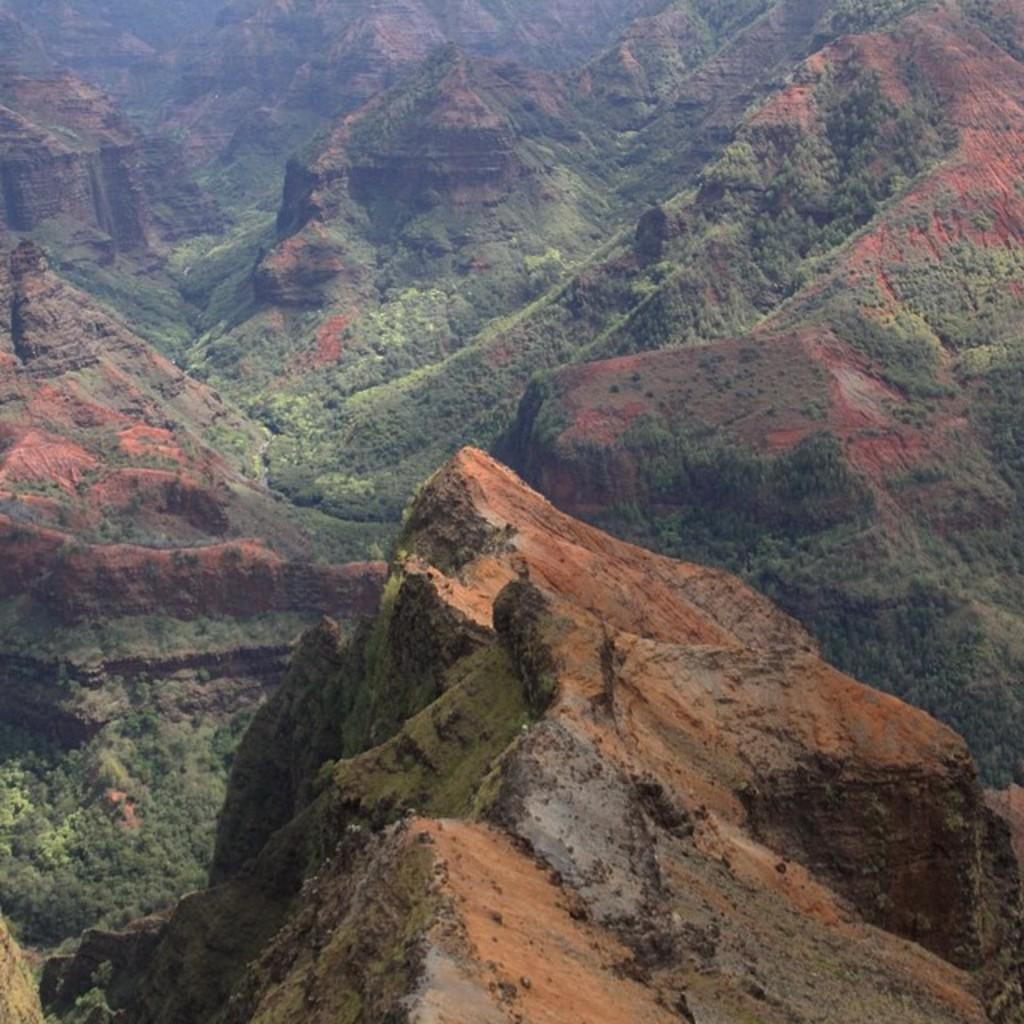What type of natural formation can be seen in the image? There are mountains in the image. What colors are the mountains? The mountains have red and green colors. How many roses are present on the mountains in the image? There are no roses present on the mountains in the image. What knowledge can be gained from the mountains in the image? The image does not convey any specific knowledge or information about the mountains. 